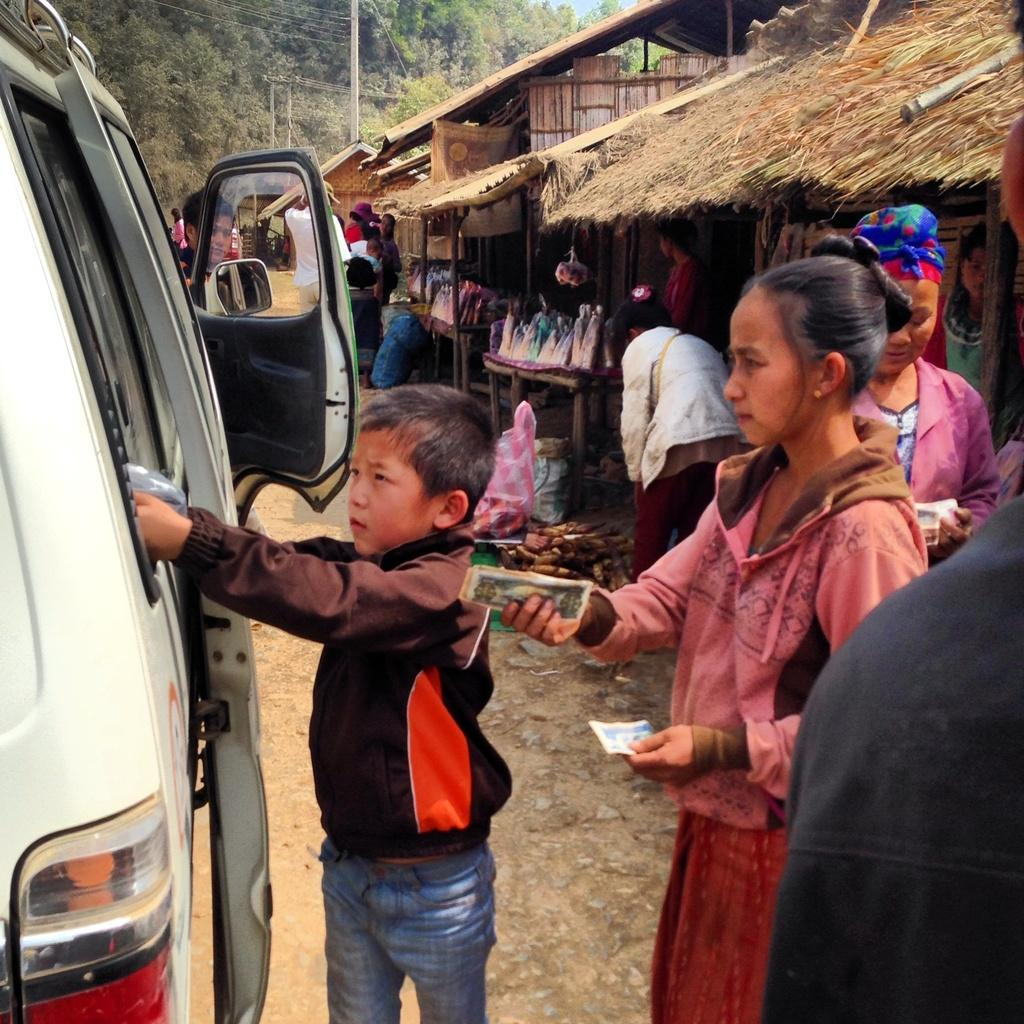What is the main subject of the image? There is a car on a road in the image. Are there any people present in the image? Yes, there are people standing near the car. What can be seen in the background of the image? There are houses and trees in the background of the image. What type of army vehicles can be seen in the image? There are no army vehicles present in the image; it features a car on a road with people standing nearby and houses and trees in the background. What book is the person reading in the image? There is no person reading a book in the image; it only shows a car, people, houses, and trees. 